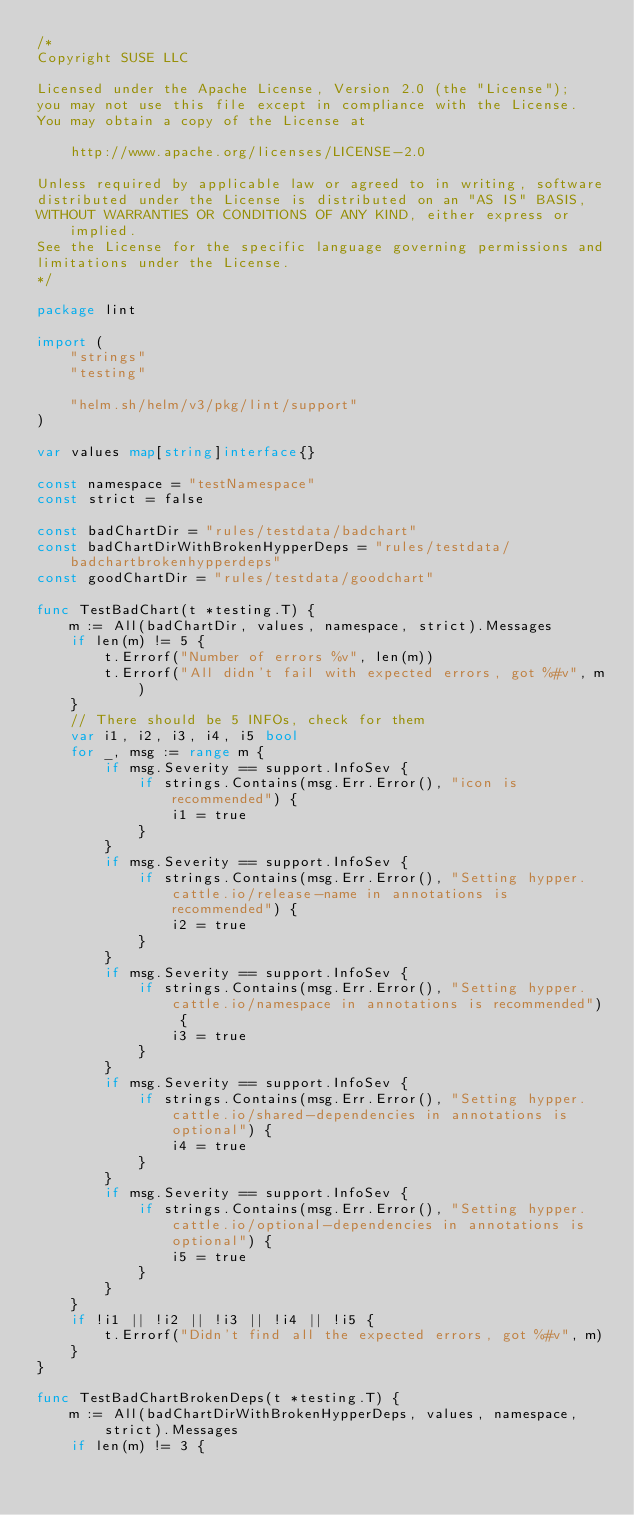Convert code to text. <code><loc_0><loc_0><loc_500><loc_500><_Go_>/*
Copyright SUSE LLC

Licensed under the Apache License, Version 2.0 (the "License");
you may not use this file except in compliance with the License.
You may obtain a copy of the License at

    http://www.apache.org/licenses/LICENSE-2.0

Unless required by applicable law or agreed to in writing, software
distributed under the License is distributed on an "AS IS" BASIS,
WITHOUT WARRANTIES OR CONDITIONS OF ANY KIND, either express or implied.
See the License for the specific language governing permissions and
limitations under the License.
*/

package lint

import (
	"strings"
	"testing"

	"helm.sh/helm/v3/pkg/lint/support"
)

var values map[string]interface{}

const namespace = "testNamespace"
const strict = false

const badChartDir = "rules/testdata/badchart"
const badChartDirWithBrokenHypperDeps = "rules/testdata/badchartbrokenhypperdeps"
const goodChartDir = "rules/testdata/goodchart"

func TestBadChart(t *testing.T) {
	m := All(badChartDir, values, namespace, strict).Messages
	if len(m) != 5 {
		t.Errorf("Number of errors %v", len(m))
		t.Errorf("All didn't fail with expected errors, got %#v", m)
	}
	// There should be 5 INFOs, check for them
	var i1, i2, i3, i4, i5 bool
	for _, msg := range m {
		if msg.Severity == support.InfoSev {
			if strings.Contains(msg.Err.Error(), "icon is recommended") {
				i1 = true
			}
		}
		if msg.Severity == support.InfoSev {
			if strings.Contains(msg.Err.Error(), "Setting hypper.cattle.io/release-name in annotations is recommended") {
				i2 = true
			}
		}
		if msg.Severity == support.InfoSev {
			if strings.Contains(msg.Err.Error(), "Setting hypper.cattle.io/namespace in annotations is recommended") {
				i3 = true
			}
		}
		if msg.Severity == support.InfoSev {
			if strings.Contains(msg.Err.Error(), "Setting hypper.cattle.io/shared-dependencies in annotations is optional") {
				i4 = true
			}
		}
		if msg.Severity == support.InfoSev {
			if strings.Contains(msg.Err.Error(), "Setting hypper.cattle.io/optional-dependencies in annotations is optional") {
				i5 = true
			}
		}
	}
	if !i1 || !i2 || !i3 || !i4 || !i5 {
		t.Errorf("Didn't find all the expected errors, got %#v", m)
	}
}

func TestBadChartBrokenDeps(t *testing.T) {
	m := All(badChartDirWithBrokenHypperDeps, values, namespace, strict).Messages
	if len(m) != 3 {</code> 